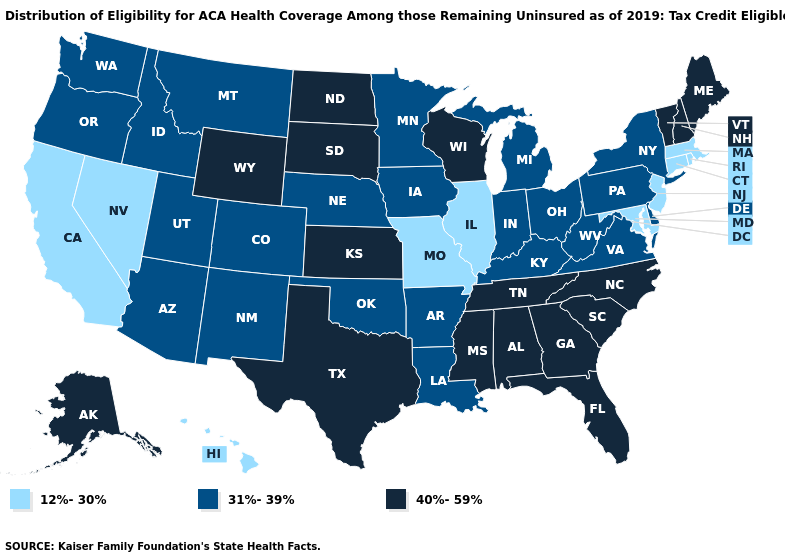Among the states that border Vermont , which have the lowest value?
Be succinct. Massachusetts. What is the value of Kansas?
Quick response, please. 40%-59%. What is the value of Michigan?
Keep it brief. 31%-39%. How many symbols are there in the legend?
Write a very short answer. 3. What is the lowest value in the USA?
Answer briefly. 12%-30%. Name the states that have a value in the range 40%-59%?
Give a very brief answer. Alabama, Alaska, Florida, Georgia, Kansas, Maine, Mississippi, New Hampshire, North Carolina, North Dakota, South Carolina, South Dakota, Tennessee, Texas, Vermont, Wisconsin, Wyoming. What is the value of Nevada?
Write a very short answer. 12%-30%. What is the lowest value in the USA?
Be succinct. 12%-30%. What is the lowest value in the MidWest?
Quick response, please. 12%-30%. What is the lowest value in the MidWest?
Short answer required. 12%-30%. Which states have the lowest value in the USA?
Quick response, please. California, Connecticut, Hawaii, Illinois, Maryland, Massachusetts, Missouri, Nevada, New Jersey, Rhode Island. What is the value of Indiana?
Short answer required. 31%-39%. Does the first symbol in the legend represent the smallest category?
Write a very short answer. Yes. Name the states that have a value in the range 40%-59%?
Keep it brief. Alabama, Alaska, Florida, Georgia, Kansas, Maine, Mississippi, New Hampshire, North Carolina, North Dakota, South Carolina, South Dakota, Tennessee, Texas, Vermont, Wisconsin, Wyoming. What is the value of Minnesota?
Answer briefly. 31%-39%. 